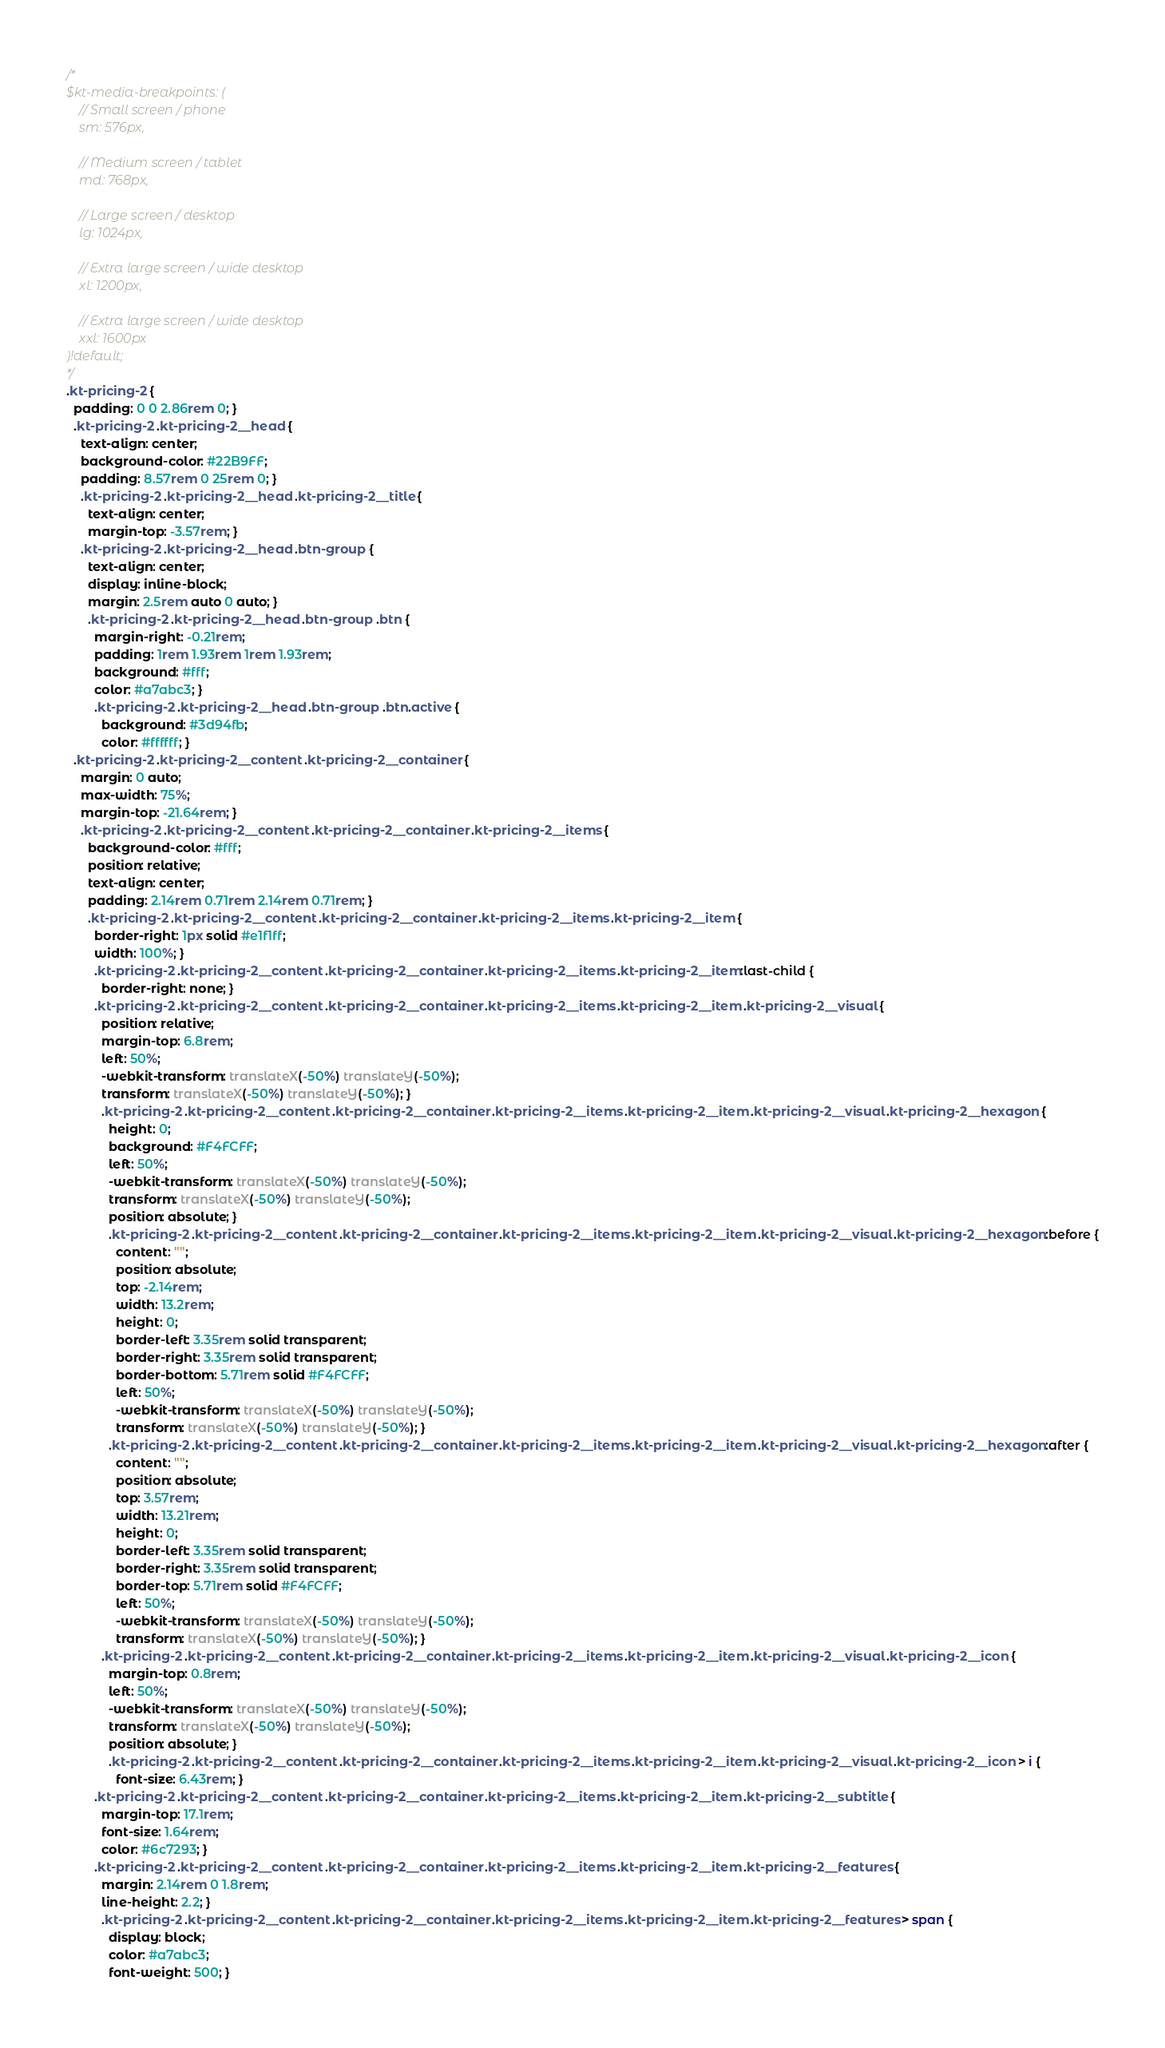<code> <loc_0><loc_0><loc_500><loc_500><_CSS_>/*
$kt-media-breakpoints: (
    // Small screen / phone
    sm: 576px,
    
    // Medium screen / tablet
    md: 768px,
    
    // Large screen / desktop
    lg: 1024px,
    
    // Extra large screen / wide desktop
    xl: 1200px,

    // Extra large screen / wide desktop
    xxl: 1600px
)!default;
*/
.kt-pricing-2 {
  padding: 0 0 2.86rem 0; }
  .kt-pricing-2 .kt-pricing-2__head {
    text-align: center;
    background-color: #22B9FF;
    padding: 8.57rem 0 25rem 0; }
    .kt-pricing-2 .kt-pricing-2__head .kt-pricing-2__title {
      text-align: center;
      margin-top: -3.57rem; }
    .kt-pricing-2 .kt-pricing-2__head .btn-group {
      text-align: center;
      display: inline-block;
      margin: 2.5rem auto 0 auto; }
      .kt-pricing-2 .kt-pricing-2__head .btn-group .btn {
        margin-right: -0.21rem;
        padding: 1rem 1.93rem 1rem 1.93rem;
        background: #fff;
        color: #a7abc3; }
        .kt-pricing-2 .kt-pricing-2__head .btn-group .btn.active {
          background: #3d94fb;
          color: #ffffff; }
  .kt-pricing-2 .kt-pricing-2__content .kt-pricing-2__container {
    margin: 0 auto;
    max-width: 75%;
    margin-top: -21.64rem; }
    .kt-pricing-2 .kt-pricing-2__content .kt-pricing-2__container .kt-pricing-2__items {
      background-color: #fff;
      position: relative;
      text-align: center;
      padding: 2.14rem 0.71rem 2.14rem 0.71rem; }
      .kt-pricing-2 .kt-pricing-2__content .kt-pricing-2__container .kt-pricing-2__items .kt-pricing-2__item {
        border-right: 1px solid #e1f1ff;
        width: 100%; }
        .kt-pricing-2 .kt-pricing-2__content .kt-pricing-2__container .kt-pricing-2__items .kt-pricing-2__item:last-child {
          border-right: none; }
        .kt-pricing-2 .kt-pricing-2__content .kt-pricing-2__container .kt-pricing-2__items .kt-pricing-2__item .kt-pricing-2__visual {
          position: relative;
          margin-top: 6.8rem;
          left: 50%;
          -webkit-transform: translateX(-50%) translateY(-50%);
          transform: translateX(-50%) translateY(-50%); }
          .kt-pricing-2 .kt-pricing-2__content .kt-pricing-2__container .kt-pricing-2__items .kt-pricing-2__item .kt-pricing-2__visual .kt-pricing-2__hexagon {
            height: 0;
            background: #F4FCFF;
            left: 50%;
            -webkit-transform: translateX(-50%) translateY(-50%);
            transform: translateX(-50%) translateY(-50%);
            position: absolute; }
            .kt-pricing-2 .kt-pricing-2__content .kt-pricing-2__container .kt-pricing-2__items .kt-pricing-2__item .kt-pricing-2__visual .kt-pricing-2__hexagon:before {
              content: "";
              position: absolute;
              top: -2.14rem;
              width: 13.2rem;
              height: 0;
              border-left: 3.35rem solid transparent;
              border-right: 3.35rem solid transparent;
              border-bottom: 5.71rem solid #F4FCFF;
              left: 50%;
              -webkit-transform: translateX(-50%) translateY(-50%);
              transform: translateX(-50%) translateY(-50%); }
            .kt-pricing-2 .kt-pricing-2__content .kt-pricing-2__container .kt-pricing-2__items .kt-pricing-2__item .kt-pricing-2__visual .kt-pricing-2__hexagon:after {
              content: "";
              position: absolute;
              top: 3.57rem;
              width: 13.21rem;
              height: 0;
              border-left: 3.35rem solid transparent;
              border-right: 3.35rem solid transparent;
              border-top: 5.71rem solid #F4FCFF;
              left: 50%;
              -webkit-transform: translateX(-50%) translateY(-50%);
              transform: translateX(-50%) translateY(-50%); }
          .kt-pricing-2 .kt-pricing-2__content .kt-pricing-2__container .kt-pricing-2__items .kt-pricing-2__item .kt-pricing-2__visual .kt-pricing-2__icon {
            margin-top: 0.8rem;
            left: 50%;
            -webkit-transform: translateX(-50%) translateY(-50%);
            transform: translateX(-50%) translateY(-50%);
            position: absolute; }
            .kt-pricing-2 .kt-pricing-2__content .kt-pricing-2__container .kt-pricing-2__items .kt-pricing-2__item .kt-pricing-2__visual .kt-pricing-2__icon > i {
              font-size: 6.43rem; }
        .kt-pricing-2 .kt-pricing-2__content .kt-pricing-2__container .kt-pricing-2__items .kt-pricing-2__item .kt-pricing-2__subtitle {
          margin-top: 17.1rem;
          font-size: 1.64rem;
          color: #6c7293; }
        .kt-pricing-2 .kt-pricing-2__content .kt-pricing-2__container .kt-pricing-2__items .kt-pricing-2__item .kt-pricing-2__features {
          margin: 2.14rem 0 1.8rem;
          line-height: 2.2; }
          .kt-pricing-2 .kt-pricing-2__content .kt-pricing-2__container .kt-pricing-2__items .kt-pricing-2__item .kt-pricing-2__features > span {
            display: block;
            color: #a7abc3;
            font-weight: 500; }</code> 